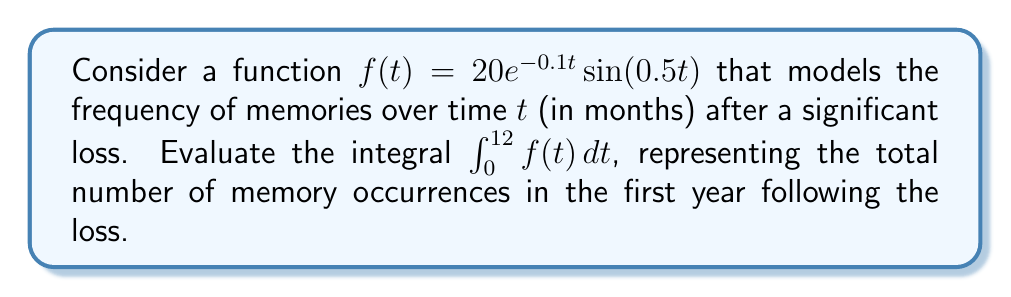Can you solve this math problem? To evaluate this integral, we'll use integration by parts twice:

1) Let $u = \sin(0.5t)$ and $dv = 20e^{-0.1t}dt$

2) Then $du = 0.5\cos(0.5t)dt$ and $v = -200e^{-0.1t}$

3) Applying integration by parts:

   $$\int_0^{12} 20e^{-0.1t}\sin(0.5t) dt = -200e^{-0.1t}\sin(0.5t)|_0^{12} + 100\int_0^{12} e^{-0.1t}\cos(0.5t) dt$$

4) Now for the remaining integral, let $u = \cos(0.5t)$ and $dv = 100e^{-0.1t}dt$

5) Then $du = -0.5\sin(0.5t)dt$ and $v = -1000e^{-0.1t}$

6) Applying integration by parts again:

   $$100\int_0^{12} e^{-0.1t}\cos(0.5t) dt = -1000e^{-0.1t}\cos(0.5t)|_0^{12} - 500\int_0^{12} e^{-0.1t}\sin(0.5t) dt$$

7) Substituting this back into the original equation:

   $$\int_0^{12} 20e^{-0.1t}\sin(0.5t) dt = -200e^{-0.1t}\sin(0.5t)|_0^{12} - 1000e^{-0.1t}\cos(0.5t)|_0^{12} - 500\int_0^{12} e^{-0.1t}\sin(0.5t) dt$$

8) Moving the integral term to the left side:

   $$1500\int_0^{12} e^{-0.1t}\sin(0.5t) dt = -200e^{-0.1t}\sin(0.5t)|_0^{12} - 1000e^{-0.1t}\cos(0.5t)|_0^{12}$$

9) Evaluating the right side:

   $$1500\int_0^{12} e^{-0.1t}\sin(0.5t) dt = -200(e^{-1.2}\sin(6) - 0) - 1000(e^{-1.2}\cos(6) - 1)$$

10) Simplifying:

    $$\int_0^{12} e^{-0.1t}\sin(0.5t) dt = \frac{-200e^{-1.2}\sin(6) - 1000e^{-1.2}\cos(6) + 1000}{1500} \approx 0.6247$$

11) Therefore, the total number of memory occurrences in the first year is approximately 12.494.
Answer: $12.494$ memory occurrences 